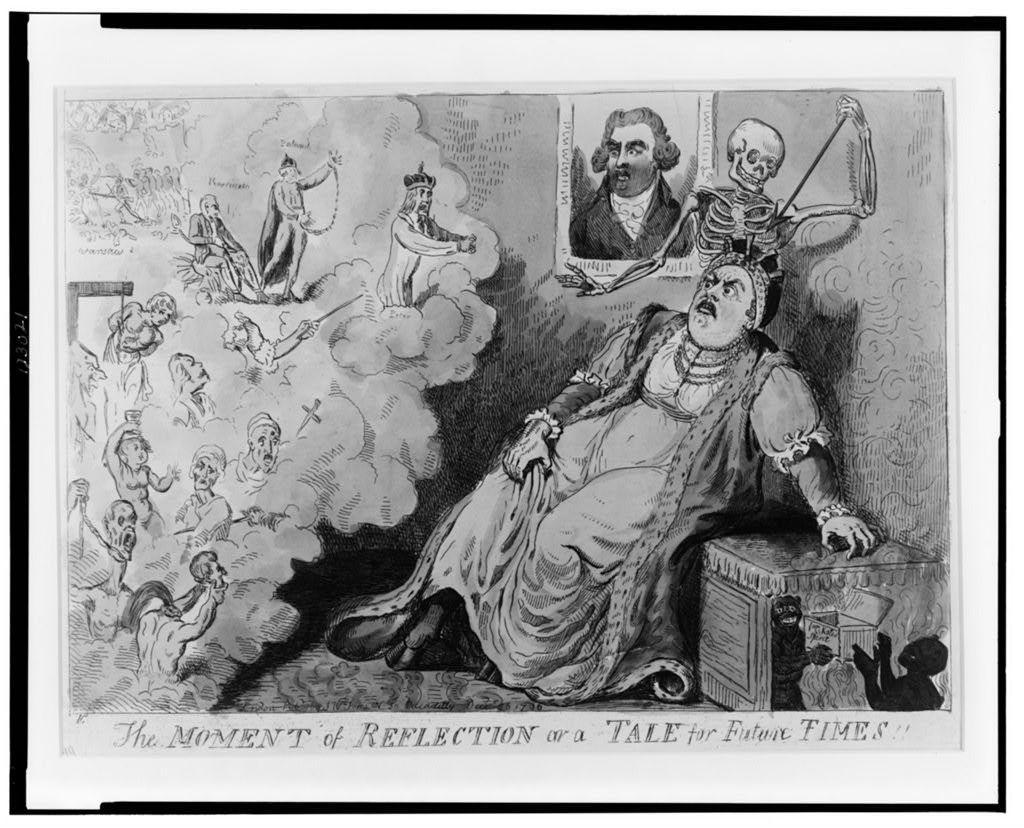How would you summarize this image in a sentence or two? This is a poster and in this poster we can see some people, frame, skeleton and some text. 